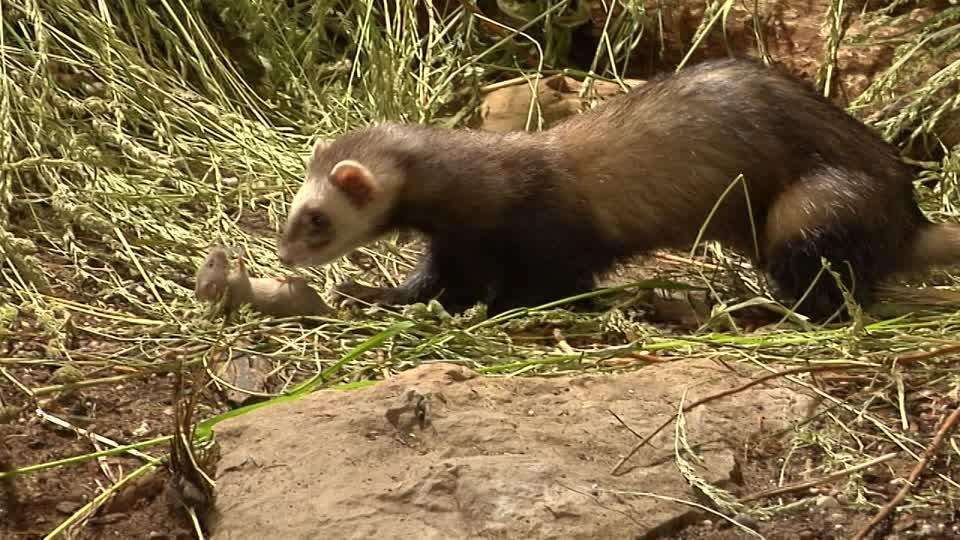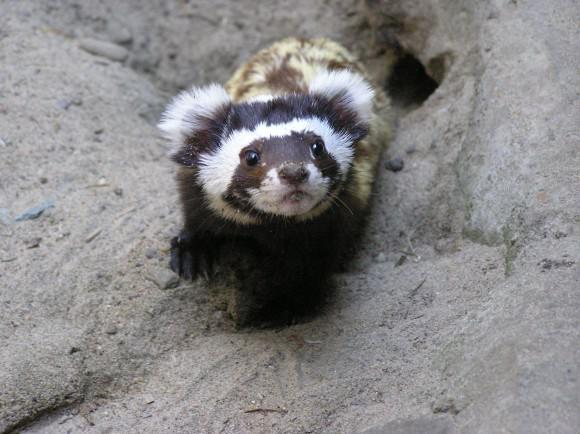The first image is the image on the left, the second image is the image on the right. Considering the images on both sides, is "there is a ferret in tall grass" valid? Answer yes or no. Yes. The first image is the image on the left, the second image is the image on the right. For the images displayed, is the sentence "The animal in one of the images is situated in the grass." factually correct? Answer yes or no. Yes. 